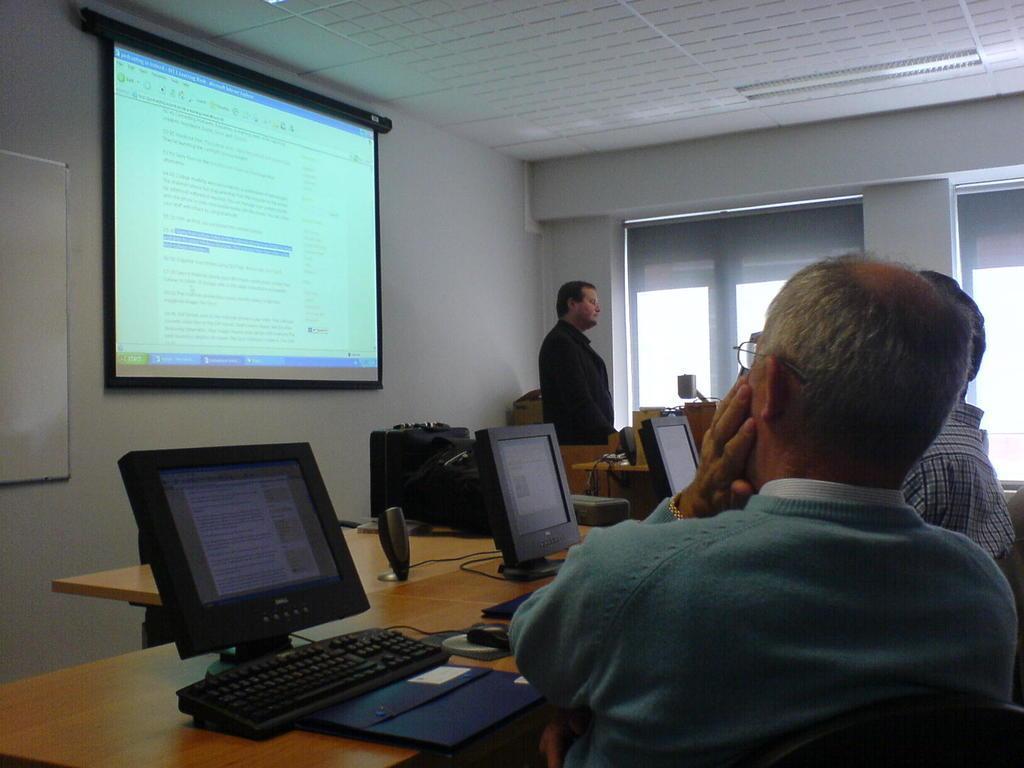Can you describe this image briefly? This is a room,on the right there are 2 persons listening to the person explaining something on the screen. On the roof there is a light. Here we have window and there are laptops on the table. 